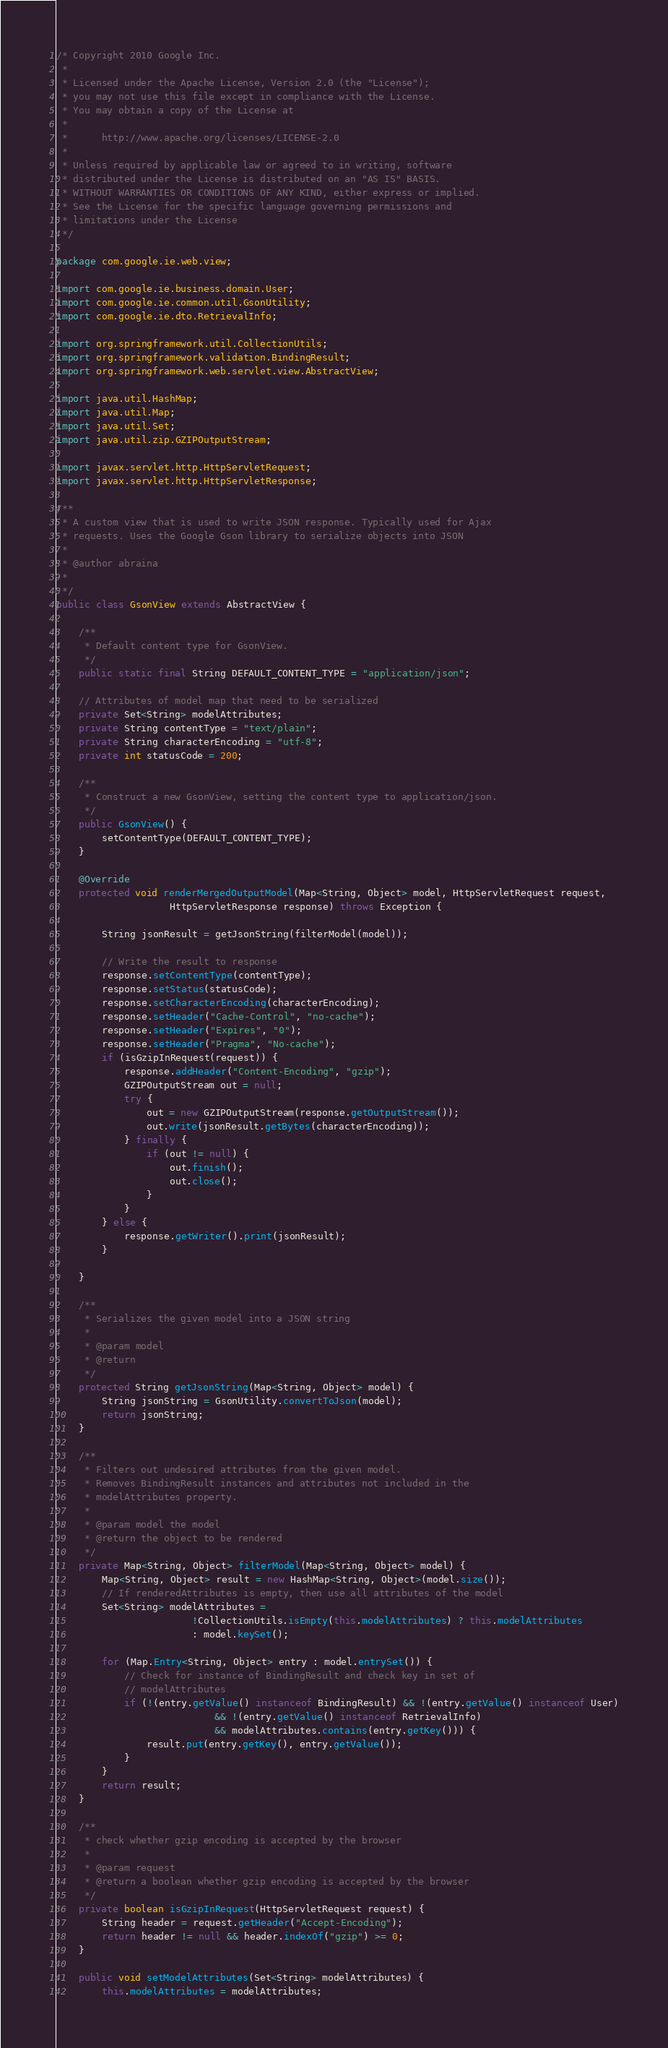Convert code to text. <code><loc_0><loc_0><loc_500><loc_500><_Java_>/* Copyright 2010 Google Inc.
 * 
 * Licensed under the Apache License, Version 2.0 (the "License");
 * you may not use this file except in compliance with the License.
 * You may obtain a copy of the License at
 * 
 *      http://www.apache.org/licenses/LICENSE-2.0
 * 
 * Unless required by applicable law or agreed to in writing, software
 * distributed under the License is distributed on an "AS IS" BASIS.
 * WITHOUT WARRANTIES OR CONDITIONS OF ANY KIND, either express or implied.
 * See the License for the specific language governing permissions and
 * limitations under the License
 */

package com.google.ie.web.view;

import com.google.ie.business.domain.User;
import com.google.ie.common.util.GsonUtility;
import com.google.ie.dto.RetrievalInfo;

import org.springframework.util.CollectionUtils;
import org.springframework.validation.BindingResult;
import org.springframework.web.servlet.view.AbstractView;

import java.util.HashMap;
import java.util.Map;
import java.util.Set;
import java.util.zip.GZIPOutputStream;

import javax.servlet.http.HttpServletRequest;
import javax.servlet.http.HttpServletResponse;

/**
 * A custom view that is used to write JSON response. Typically used for Ajax
 * requests. Uses the Google Gson library to serialize objects into JSON
 * 
 * @author abraina
 * 
 */
public class GsonView extends AbstractView {

    /**
     * Default content type for GsonView.
     */
    public static final String DEFAULT_CONTENT_TYPE = "application/json";

    // Attributes of model map that need to be serialized
    private Set<String> modelAttributes;
    private String contentType = "text/plain";
    private String characterEncoding = "utf-8";
    private int statusCode = 200;

    /**
     * Construct a new GsonView, setting the content type to application/json.
     */
    public GsonView() {
        setContentType(DEFAULT_CONTENT_TYPE);
    }

    @Override
    protected void renderMergedOutputModel(Map<String, Object> model, HttpServletRequest request,
                    HttpServletResponse response) throws Exception {

        String jsonResult = getJsonString(filterModel(model));

        // Write the result to response
        response.setContentType(contentType);
        response.setStatus(statusCode);
        response.setCharacterEncoding(characterEncoding);
        response.setHeader("Cache-Control", "no-cache");
        response.setHeader("Expires", "0");
        response.setHeader("Pragma", "No-cache");
        if (isGzipInRequest(request)) {
            response.addHeader("Content-Encoding", "gzip");
            GZIPOutputStream out = null;
            try {
                out = new GZIPOutputStream(response.getOutputStream());
                out.write(jsonResult.getBytes(characterEncoding));
            } finally {
                if (out != null) {
                    out.finish();
                    out.close();
                }
            }
        } else {
            response.getWriter().print(jsonResult);
        }

    }

    /**
     * Serializes the given model into a JSON string
     * 
     * @param model
     * @return
     */
    protected String getJsonString(Map<String, Object> model) {
        String jsonString = GsonUtility.convertToJson(model);
        return jsonString;
    }

    /**
     * Filters out undesired attributes from the given model.
     * Removes BindingResult instances and attributes not included in the
     * modelAttributes property.
     * 
     * @param model the model
     * @return the object to be rendered
     */
    private Map<String, Object> filterModel(Map<String, Object> model) {
        Map<String, Object> result = new HashMap<String, Object>(model.size());
        // If renderedAttributes is empty, then use all attributes of the model
        Set<String> modelAttributes =
                        !CollectionUtils.isEmpty(this.modelAttributes) ? this.modelAttributes
                        : model.keySet();

        for (Map.Entry<String, Object> entry : model.entrySet()) {
            // Check for instance of BindingResult and check key in set of
            // modelAttributes
            if (!(entry.getValue() instanceof BindingResult) && !(entry.getValue() instanceof User)
                            && !(entry.getValue() instanceof RetrievalInfo)
                            && modelAttributes.contains(entry.getKey())) {
                result.put(entry.getKey(), entry.getValue());
            }
        }
        return result;
    }

    /**
     * check whether gzip encoding is accepted by the browser
     * 
     * @param request
     * @return a boolean whether gzip encoding is accepted by the browser
     */
    private boolean isGzipInRequest(HttpServletRequest request) {
        String header = request.getHeader("Accept-Encoding");
        return header != null && header.indexOf("gzip") >= 0;
    }

    public void setModelAttributes(Set<String> modelAttributes) {
        this.modelAttributes = modelAttributes;</code> 